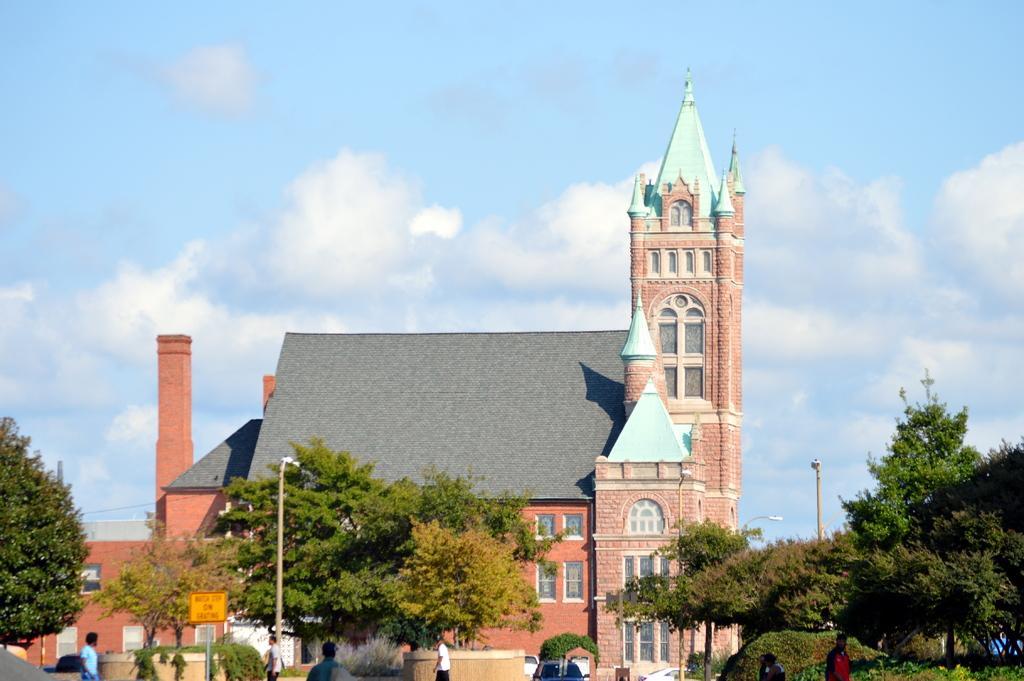Please provide a concise description of this image. In this image we can see a building, there are some poles, lights, trees, plants, vehicles, windows and people, in the background, we can see the sky with clouds. 